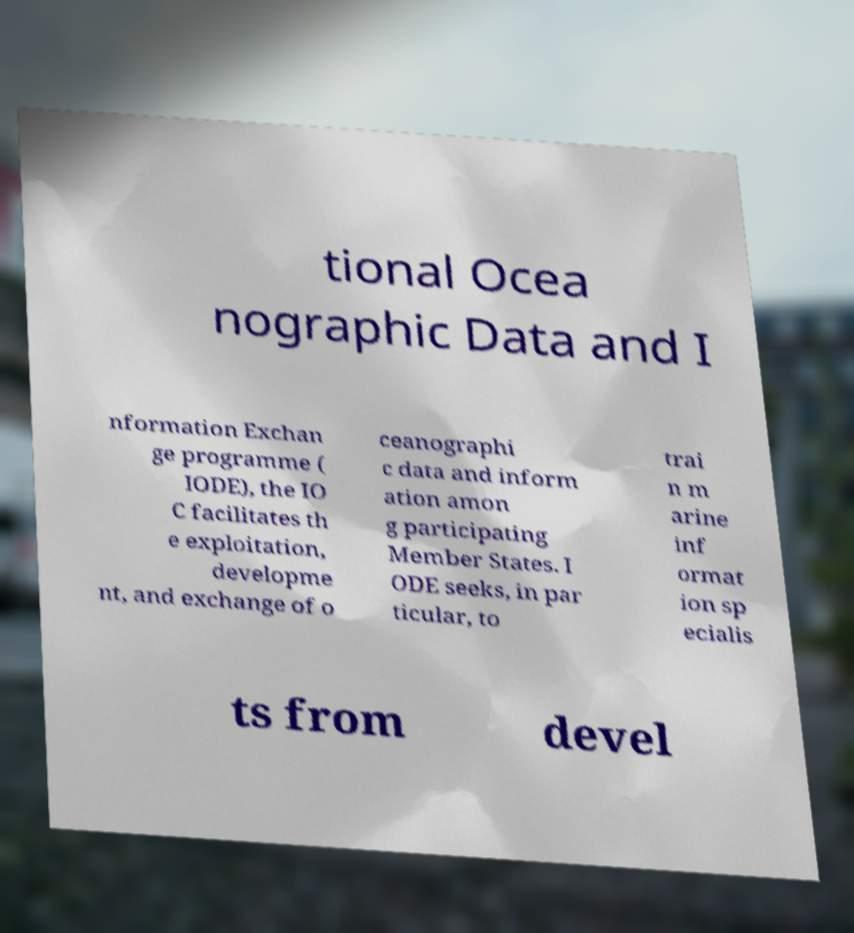I need the written content from this picture converted into text. Can you do that? tional Ocea nographic Data and I nformation Exchan ge programme ( IODE), the IO C facilitates th e exploitation, developme nt, and exchange of o ceanographi c data and inform ation amon g participating Member States. I ODE seeks, in par ticular, to trai n m arine inf ormat ion sp ecialis ts from devel 